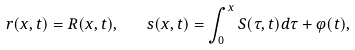<formula> <loc_0><loc_0><loc_500><loc_500>r ( x , t ) = R ( x , t ) , \quad s ( x , t ) = \int _ { 0 } ^ { x } S ( \tau , t ) d \tau + \varphi ( t ) ,</formula> 